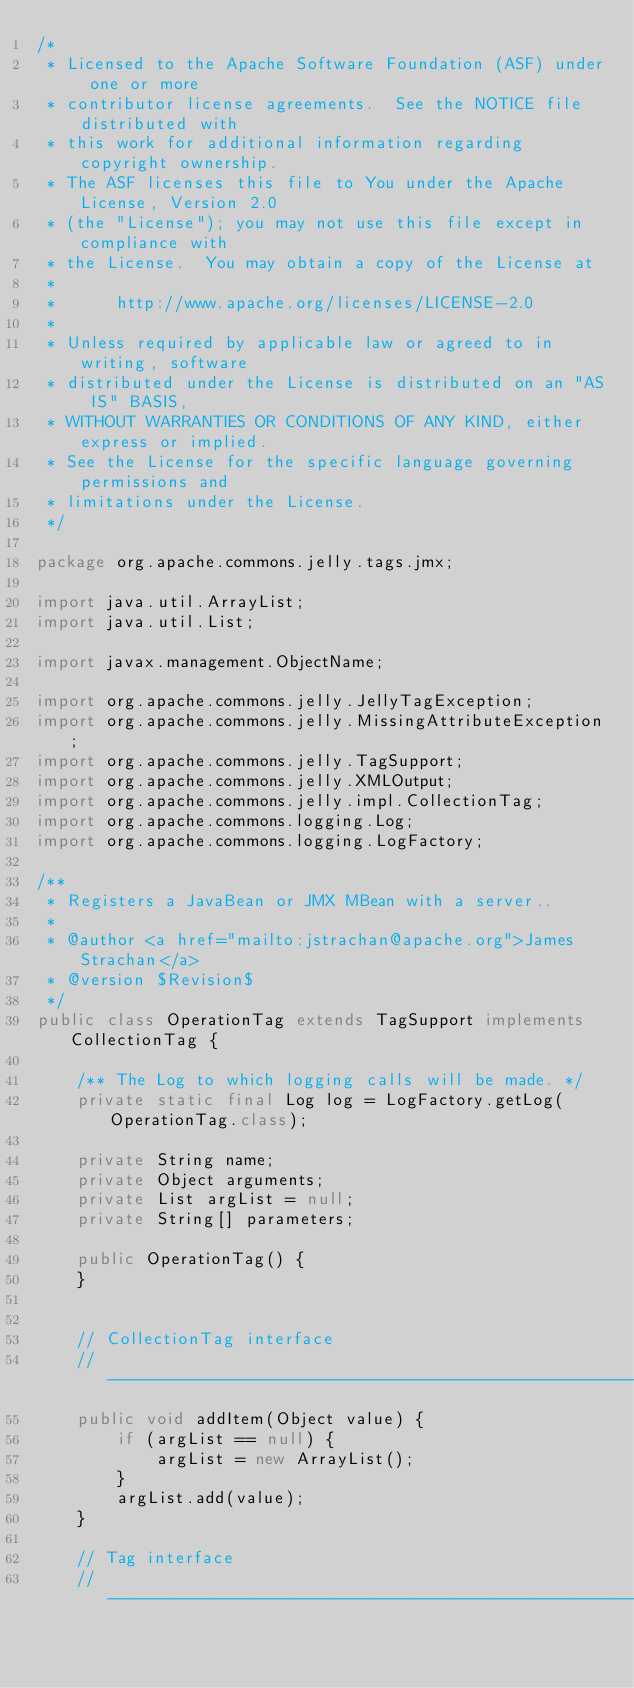Convert code to text. <code><loc_0><loc_0><loc_500><loc_500><_Java_>/*
 * Licensed to the Apache Software Foundation (ASF) under one or more
 * contributor license agreements.  See the NOTICE file distributed with
 * this work for additional information regarding copyright ownership.
 * The ASF licenses this file to You under the Apache License, Version 2.0
 * (the "License"); you may not use this file except in compliance with
 * the License.  You may obtain a copy of the License at
 *
 *      http://www.apache.org/licenses/LICENSE-2.0
 *
 * Unless required by applicable law or agreed to in writing, software
 * distributed under the License is distributed on an "AS IS" BASIS,
 * WITHOUT WARRANTIES OR CONDITIONS OF ANY KIND, either express or implied.
 * See the License for the specific language governing permissions and
 * limitations under the License.
 */

package org.apache.commons.jelly.tags.jmx;

import java.util.ArrayList;
import java.util.List;

import javax.management.ObjectName;

import org.apache.commons.jelly.JellyTagException;
import org.apache.commons.jelly.MissingAttributeException;
import org.apache.commons.jelly.TagSupport;
import org.apache.commons.jelly.XMLOutput;
import org.apache.commons.jelly.impl.CollectionTag;
import org.apache.commons.logging.Log;
import org.apache.commons.logging.LogFactory;

/**
 * Registers a JavaBean or JMX MBean with a server..
 *
 * @author <a href="mailto:jstrachan@apache.org">James Strachan</a>
 * @version $Revision$
 */
public class OperationTag extends TagSupport implements CollectionTag {

    /** The Log to which logging calls will be made. */
    private static final Log log = LogFactory.getLog(OperationTag.class);

    private String name;
    private Object arguments;
    private List argList = null;
    private String[] parameters;

    public OperationTag() {
    }


    // CollectionTag interface
    //-------------------------------------------------------------------------
    public void addItem(Object value) {
        if (argList == null) {
            argList = new ArrayList();
        }
        argList.add(value);
    }

    // Tag interface
    //-------------------------------------------------------------------------</code> 